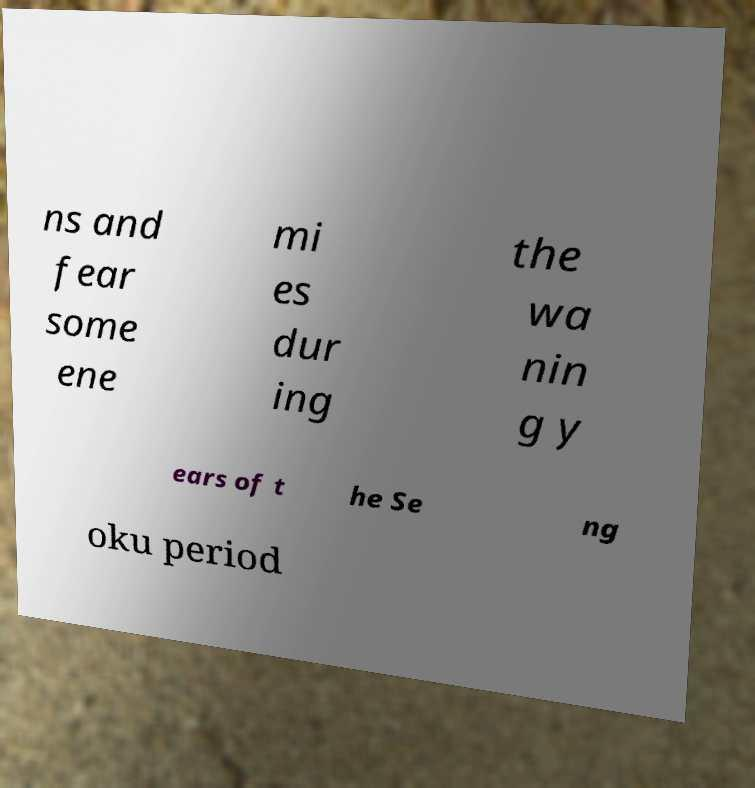Can you read and provide the text displayed in the image?This photo seems to have some interesting text. Can you extract and type it out for me? ns and fear some ene mi es dur ing the wa nin g y ears of t he Se ng oku period 